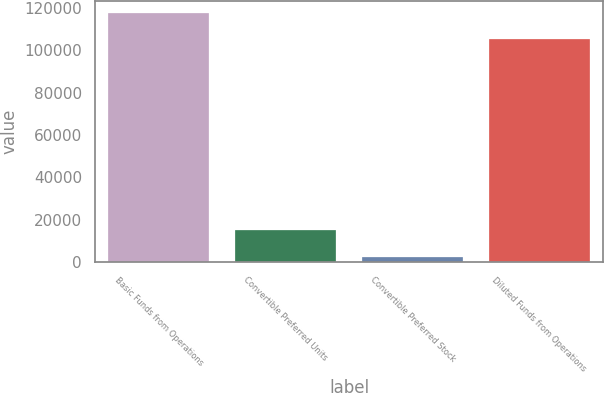<chart> <loc_0><loc_0><loc_500><loc_500><bar_chart><fcel>Basic Funds from Operations<fcel>Convertible Preferred Units<fcel>Convertible Preferred Stock<fcel>Diluted Funds from Operations<nl><fcel>117521<fcel>14961.2<fcel>2625<fcel>105185<nl></chart> 